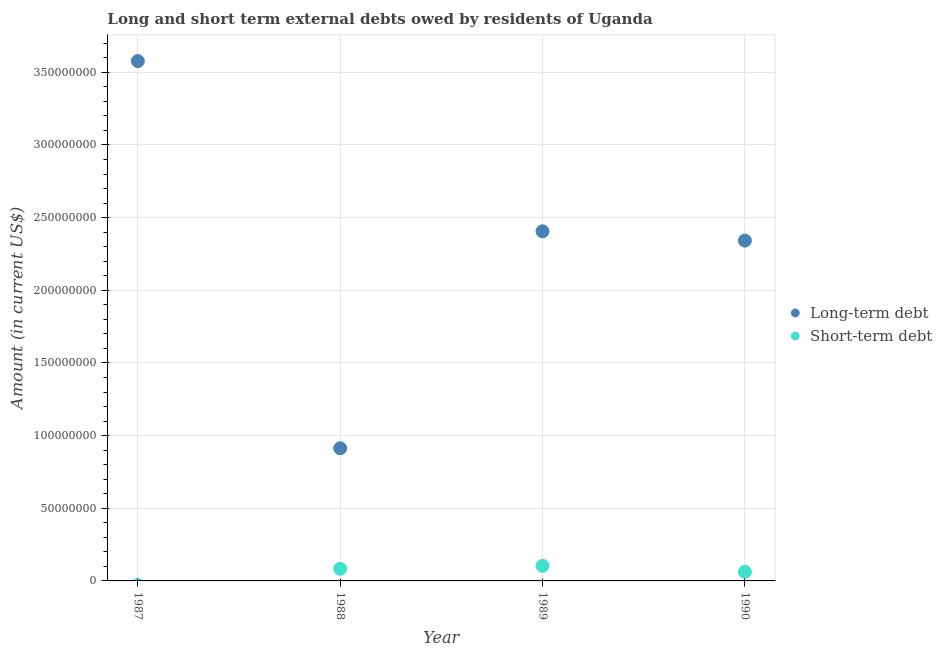Is the number of dotlines equal to the number of legend labels?
Your answer should be very brief. No. What is the short-term debts owed by residents in 1990?
Your answer should be very brief. 6.26e+06. Across all years, what is the maximum short-term debts owed by residents?
Your response must be concise. 1.04e+07. Across all years, what is the minimum long-term debts owed by residents?
Your answer should be compact. 9.13e+07. In which year was the long-term debts owed by residents maximum?
Offer a terse response. 1987. What is the total long-term debts owed by residents in the graph?
Ensure brevity in your answer.  9.24e+08. What is the difference between the long-term debts owed by residents in 1988 and that in 1989?
Offer a very short reply. -1.49e+08. What is the difference between the short-term debts owed by residents in 1987 and the long-term debts owed by residents in 1988?
Offer a very short reply. -9.13e+07. What is the average long-term debts owed by residents per year?
Make the answer very short. 2.31e+08. In the year 1989, what is the difference between the long-term debts owed by residents and short-term debts owed by residents?
Offer a terse response. 2.30e+08. What is the ratio of the long-term debts owed by residents in 1989 to that in 1990?
Ensure brevity in your answer.  1.03. What is the difference between the highest and the second highest long-term debts owed by residents?
Your response must be concise. 1.17e+08. What is the difference between the highest and the lowest short-term debts owed by residents?
Provide a short and direct response. 1.04e+07. In how many years, is the short-term debts owed by residents greater than the average short-term debts owed by residents taken over all years?
Make the answer very short. 3. Is the sum of the long-term debts owed by residents in 1987 and 1990 greater than the maximum short-term debts owed by residents across all years?
Ensure brevity in your answer.  Yes. Is the long-term debts owed by residents strictly greater than the short-term debts owed by residents over the years?
Ensure brevity in your answer.  Yes. Is the long-term debts owed by residents strictly less than the short-term debts owed by residents over the years?
Give a very brief answer. No. How many dotlines are there?
Your response must be concise. 2. How many years are there in the graph?
Provide a succinct answer. 4. What is the difference between two consecutive major ticks on the Y-axis?
Keep it short and to the point. 5.00e+07. Are the values on the major ticks of Y-axis written in scientific E-notation?
Give a very brief answer. No. Does the graph contain grids?
Your answer should be compact. Yes. How are the legend labels stacked?
Give a very brief answer. Vertical. What is the title of the graph?
Your response must be concise. Long and short term external debts owed by residents of Uganda. What is the Amount (in current US$) of Long-term debt in 1987?
Offer a terse response. 3.58e+08. What is the Amount (in current US$) of Long-term debt in 1988?
Give a very brief answer. 9.13e+07. What is the Amount (in current US$) of Short-term debt in 1988?
Your answer should be compact. 8.37e+06. What is the Amount (in current US$) in Long-term debt in 1989?
Provide a short and direct response. 2.41e+08. What is the Amount (in current US$) in Short-term debt in 1989?
Keep it short and to the point. 1.04e+07. What is the Amount (in current US$) of Long-term debt in 1990?
Your response must be concise. 2.34e+08. What is the Amount (in current US$) of Short-term debt in 1990?
Keep it short and to the point. 6.26e+06. Across all years, what is the maximum Amount (in current US$) of Long-term debt?
Your answer should be very brief. 3.58e+08. Across all years, what is the maximum Amount (in current US$) of Short-term debt?
Ensure brevity in your answer.  1.04e+07. Across all years, what is the minimum Amount (in current US$) of Long-term debt?
Give a very brief answer. 9.13e+07. What is the total Amount (in current US$) of Long-term debt in the graph?
Make the answer very short. 9.24e+08. What is the total Amount (in current US$) in Short-term debt in the graph?
Ensure brevity in your answer.  2.50e+07. What is the difference between the Amount (in current US$) in Long-term debt in 1987 and that in 1988?
Ensure brevity in your answer.  2.66e+08. What is the difference between the Amount (in current US$) of Long-term debt in 1987 and that in 1989?
Make the answer very short. 1.17e+08. What is the difference between the Amount (in current US$) in Long-term debt in 1987 and that in 1990?
Offer a very short reply. 1.24e+08. What is the difference between the Amount (in current US$) of Long-term debt in 1988 and that in 1989?
Provide a short and direct response. -1.49e+08. What is the difference between the Amount (in current US$) in Long-term debt in 1988 and that in 1990?
Offer a very short reply. -1.43e+08. What is the difference between the Amount (in current US$) in Short-term debt in 1988 and that in 1990?
Your answer should be compact. 2.11e+06. What is the difference between the Amount (in current US$) in Long-term debt in 1989 and that in 1990?
Your answer should be very brief. 6.41e+06. What is the difference between the Amount (in current US$) in Short-term debt in 1989 and that in 1990?
Your answer should be very brief. 4.11e+06. What is the difference between the Amount (in current US$) in Long-term debt in 1987 and the Amount (in current US$) in Short-term debt in 1988?
Provide a short and direct response. 3.49e+08. What is the difference between the Amount (in current US$) in Long-term debt in 1987 and the Amount (in current US$) in Short-term debt in 1989?
Offer a terse response. 3.47e+08. What is the difference between the Amount (in current US$) of Long-term debt in 1987 and the Amount (in current US$) of Short-term debt in 1990?
Keep it short and to the point. 3.51e+08. What is the difference between the Amount (in current US$) of Long-term debt in 1988 and the Amount (in current US$) of Short-term debt in 1989?
Give a very brief answer. 8.09e+07. What is the difference between the Amount (in current US$) in Long-term debt in 1988 and the Amount (in current US$) in Short-term debt in 1990?
Your answer should be very brief. 8.50e+07. What is the difference between the Amount (in current US$) in Long-term debt in 1989 and the Amount (in current US$) in Short-term debt in 1990?
Provide a short and direct response. 2.34e+08. What is the average Amount (in current US$) in Long-term debt per year?
Your answer should be very brief. 2.31e+08. What is the average Amount (in current US$) in Short-term debt per year?
Your response must be concise. 6.25e+06. In the year 1988, what is the difference between the Amount (in current US$) in Long-term debt and Amount (in current US$) in Short-term debt?
Provide a short and direct response. 8.29e+07. In the year 1989, what is the difference between the Amount (in current US$) in Long-term debt and Amount (in current US$) in Short-term debt?
Provide a succinct answer. 2.30e+08. In the year 1990, what is the difference between the Amount (in current US$) in Long-term debt and Amount (in current US$) in Short-term debt?
Give a very brief answer. 2.28e+08. What is the ratio of the Amount (in current US$) of Long-term debt in 1987 to that in 1988?
Your answer should be compact. 3.92. What is the ratio of the Amount (in current US$) of Long-term debt in 1987 to that in 1989?
Your answer should be very brief. 1.49. What is the ratio of the Amount (in current US$) in Long-term debt in 1987 to that in 1990?
Your answer should be very brief. 1.53. What is the ratio of the Amount (in current US$) of Long-term debt in 1988 to that in 1989?
Your response must be concise. 0.38. What is the ratio of the Amount (in current US$) of Short-term debt in 1988 to that in 1989?
Your response must be concise. 0.81. What is the ratio of the Amount (in current US$) of Long-term debt in 1988 to that in 1990?
Offer a very short reply. 0.39. What is the ratio of the Amount (in current US$) in Short-term debt in 1988 to that in 1990?
Your response must be concise. 1.34. What is the ratio of the Amount (in current US$) of Long-term debt in 1989 to that in 1990?
Provide a succinct answer. 1.03. What is the ratio of the Amount (in current US$) of Short-term debt in 1989 to that in 1990?
Provide a short and direct response. 1.66. What is the difference between the highest and the second highest Amount (in current US$) of Long-term debt?
Give a very brief answer. 1.17e+08. What is the difference between the highest and the lowest Amount (in current US$) in Long-term debt?
Provide a short and direct response. 2.66e+08. What is the difference between the highest and the lowest Amount (in current US$) in Short-term debt?
Offer a very short reply. 1.04e+07. 